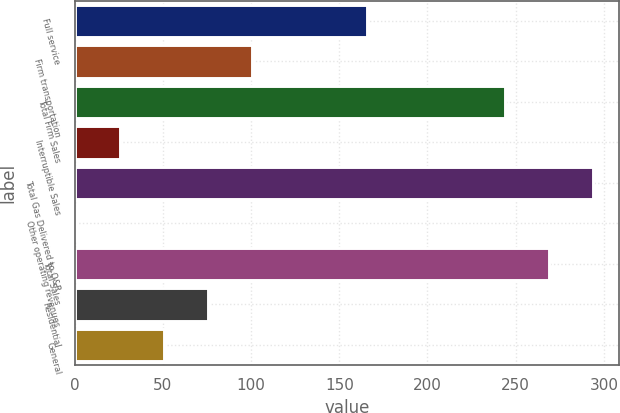<chart> <loc_0><loc_0><loc_500><loc_500><bar_chart><fcel>Full service<fcel>Firm transportation<fcel>Total Firm Sales<fcel>Interruptible Sales<fcel>Total Gas Delivered to O&R<fcel>Other operating revenues<fcel>Total Sales<fcel>Residential<fcel>General<nl><fcel>166<fcel>100.6<fcel>244<fcel>25.9<fcel>293.8<fcel>1<fcel>268.9<fcel>75.7<fcel>50.8<nl></chart> 